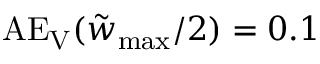Convert formula to latex. <formula><loc_0><loc_0><loc_500><loc_500>A E _ { V } ( \tilde { w } _ { \max } / 2 ) = 0 . 1</formula> 